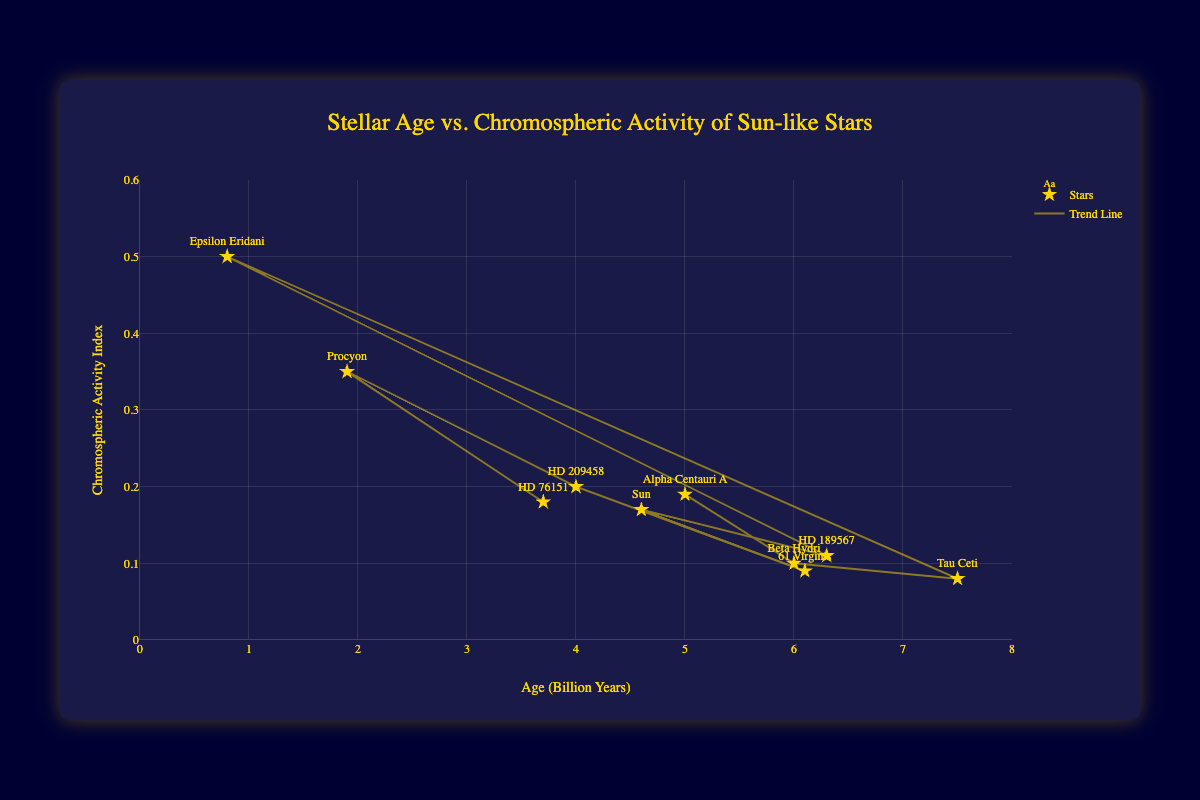What is the title of the figure? The title is visible at the top of the chart. It indicates the relationship being analyzed.
Answer: Stellar Age vs. Chromospheric Activity of Sun-like Stars What are the labels of the x-axis and y-axis? The labels for the axes are provided on the figure. The x-axis has the label indicating age, and the y-axis has the label for chromospheric activity.
Answer: Age (Billion Years) and Chromospheric Activity Index How many stars are represented in the scatter plot? Count the number of data points or stars mentioned in the data section or shown on the plot.
Answer: 10 Which star has the highest chromospheric activity index and what is that value? Find the data point with the highest chromospheric activity index value, either by inspecting the plot or checking the dataset.
Answer: Epsilon Eridani, 0.50 Which star has the smallest age, and what is its chromospheric activity index? Identify the data point with the smallest age value and check its corresponding chromospheric activity index value.
Answer: Epsilon Eridani, 0.50 How does the chromospheric activity index change with increasing age according to the trend line? Observe the trend line to understand the general direction of the chromospheric activity index as the age increases.
Answer: It decreases Which stars have both an age above 6 billion years and a chromospheric activity index below 0.1? Look for stars where the age is > 6 billion years and chromospheric activity is < 0.1 by checking the plot or dataset.
Answer: Beta Hydri, Tau Ceti Which star has the second highest chromospheric activity index and what is that value? Identify the star with the second highest chromospheric activity index from the plot or data.
Answer: Procyon, 0.35 